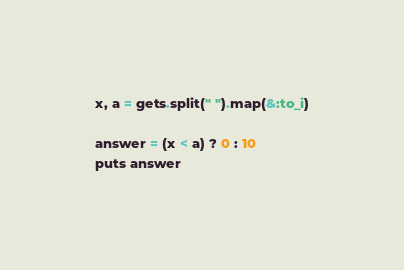Convert code to text. <code><loc_0><loc_0><loc_500><loc_500><_Ruby_>x, a = gets.split(" ").map(&:to_i)

answer = (x < a) ? 0 : 10
puts answer</code> 